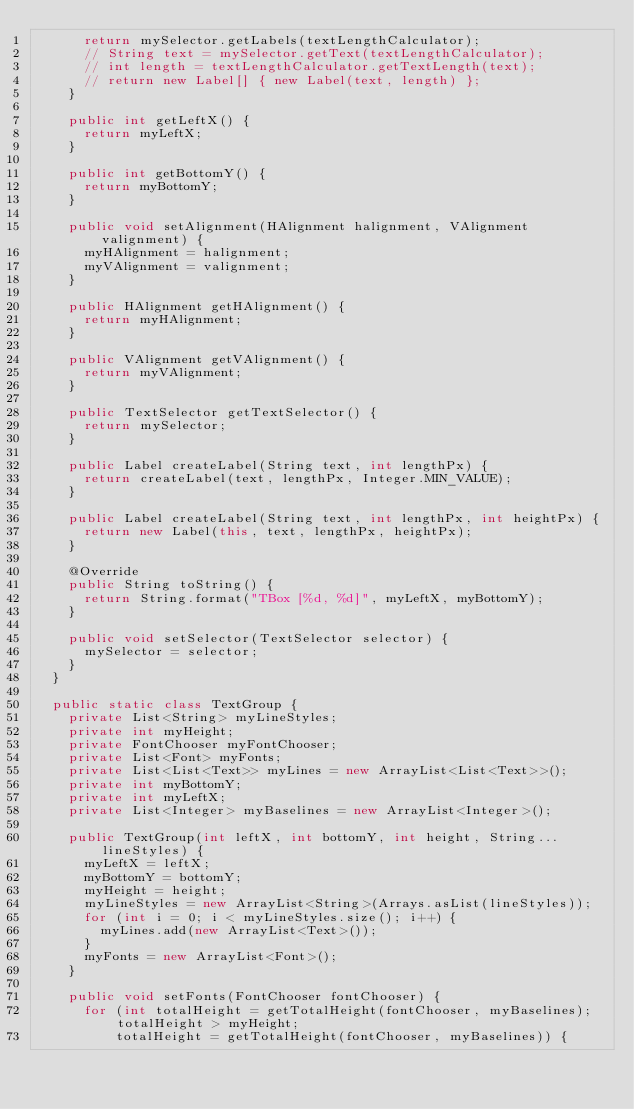Convert code to text. <code><loc_0><loc_0><loc_500><loc_500><_Java_>      return mySelector.getLabels(textLengthCalculator);
      // String text = mySelector.getText(textLengthCalculator);
      // int length = textLengthCalculator.getTextLength(text);
      // return new Label[] { new Label(text, length) };
    }

    public int getLeftX() {
      return myLeftX;
    }

    public int getBottomY() {
      return myBottomY;
    }

    public void setAlignment(HAlignment halignment, VAlignment valignment) {
      myHAlignment = halignment;
      myVAlignment = valignment;
    }

    public HAlignment getHAlignment() {
      return myHAlignment;
    }

    public VAlignment getVAlignment() {
      return myVAlignment;
    }

    public TextSelector getTextSelector() {
      return mySelector;
    }

    public Label createLabel(String text, int lengthPx) {
      return createLabel(text, lengthPx, Integer.MIN_VALUE);
    }

    public Label createLabel(String text, int lengthPx, int heightPx) {
      return new Label(this, text, lengthPx, heightPx);
    }

    @Override
    public String toString() {
      return String.format("TBox [%d, %d]", myLeftX, myBottomY);
    }

    public void setSelector(TextSelector selector) {
      mySelector = selector;
    }
  }

  public static class TextGroup {
    private List<String> myLineStyles;
    private int myHeight;
    private FontChooser myFontChooser;
    private List<Font> myFonts;
    private List<List<Text>> myLines = new ArrayList<List<Text>>();
    private int myBottomY;
    private int myLeftX;
    private List<Integer> myBaselines = new ArrayList<Integer>();

    public TextGroup(int leftX, int bottomY, int height, String... lineStyles) {
      myLeftX = leftX;
      myBottomY = bottomY;
      myHeight = height;
      myLineStyles = new ArrayList<String>(Arrays.asList(lineStyles));
      for (int i = 0; i < myLineStyles.size(); i++) {
        myLines.add(new ArrayList<Text>());
      }
      myFonts = new ArrayList<Font>();
    }

    public void setFonts(FontChooser fontChooser) {
      for (int totalHeight = getTotalHeight(fontChooser, myBaselines); totalHeight > myHeight;
          totalHeight = getTotalHeight(fontChooser, myBaselines)) {</code> 